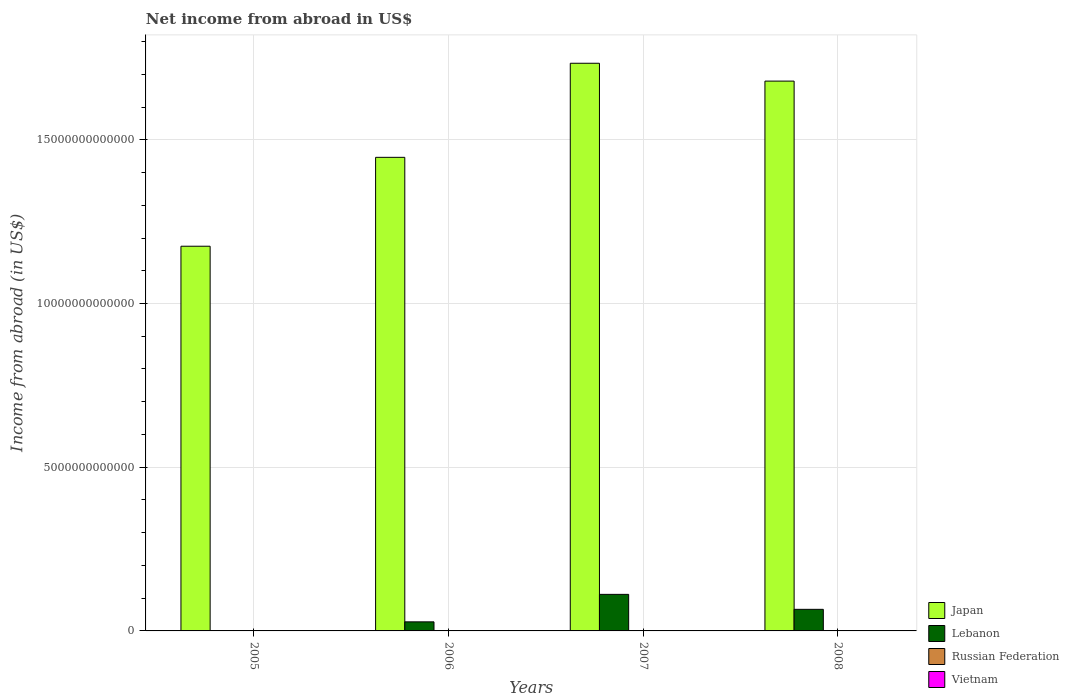Are the number of bars per tick equal to the number of legend labels?
Keep it short and to the point. No. Are the number of bars on each tick of the X-axis equal?
Your response must be concise. No. How many bars are there on the 3rd tick from the left?
Provide a succinct answer. 2. Across all years, what is the maximum net income from abroad in Lebanon?
Offer a very short reply. 1.12e+12. In which year was the net income from abroad in Lebanon maximum?
Your answer should be very brief. 2007. What is the total net income from abroad in Lebanon in the graph?
Make the answer very short. 2.05e+12. What is the difference between the net income from abroad in Lebanon in 2007 and that in 2008?
Keep it short and to the point. 4.58e+11. What is the difference between the net income from abroad in Lebanon in 2008 and the net income from abroad in Japan in 2007?
Give a very brief answer. -1.67e+13. What is the average net income from abroad in Lebanon per year?
Your answer should be compact. 5.13e+11. What is the ratio of the net income from abroad in Japan in 2005 to that in 2007?
Make the answer very short. 0.68. Is the net income from abroad in Japan in 2007 less than that in 2008?
Keep it short and to the point. No. What is the difference between the highest and the second highest net income from abroad in Japan?
Offer a very short reply. 5.45e+11. What is the difference between the highest and the lowest net income from abroad in Lebanon?
Offer a terse response. 1.12e+12. In how many years, is the net income from abroad in Japan greater than the average net income from abroad in Japan taken over all years?
Your answer should be very brief. 2. Is the sum of the net income from abroad in Japan in 2007 and 2008 greater than the maximum net income from abroad in Lebanon across all years?
Ensure brevity in your answer.  Yes. Is it the case that in every year, the sum of the net income from abroad in Vietnam and net income from abroad in Russian Federation is greater than the sum of net income from abroad in Japan and net income from abroad in Lebanon?
Give a very brief answer. No. Is it the case that in every year, the sum of the net income from abroad in Russian Federation and net income from abroad in Lebanon is greater than the net income from abroad in Japan?
Make the answer very short. No. What is the difference between two consecutive major ticks on the Y-axis?
Provide a succinct answer. 5.00e+12. Are the values on the major ticks of Y-axis written in scientific E-notation?
Keep it short and to the point. No. Does the graph contain any zero values?
Your answer should be very brief. Yes. Does the graph contain grids?
Offer a terse response. Yes. How are the legend labels stacked?
Your answer should be very brief. Vertical. What is the title of the graph?
Your response must be concise. Net income from abroad in US$. Does "Singapore" appear as one of the legend labels in the graph?
Offer a terse response. No. What is the label or title of the Y-axis?
Make the answer very short. Income from abroad (in US$). What is the Income from abroad (in US$) in Japan in 2005?
Offer a very short reply. 1.17e+13. What is the Income from abroad (in US$) in Russian Federation in 2005?
Make the answer very short. 0. What is the Income from abroad (in US$) of Vietnam in 2005?
Your response must be concise. 0. What is the Income from abroad (in US$) in Japan in 2006?
Make the answer very short. 1.45e+13. What is the Income from abroad (in US$) of Lebanon in 2006?
Your answer should be very brief. 2.77e+11. What is the Income from abroad (in US$) in Japan in 2007?
Offer a very short reply. 1.73e+13. What is the Income from abroad (in US$) of Lebanon in 2007?
Keep it short and to the point. 1.12e+12. What is the Income from abroad (in US$) in Japan in 2008?
Your answer should be compact. 1.68e+13. What is the Income from abroad (in US$) in Lebanon in 2008?
Offer a terse response. 6.59e+11. What is the Income from abroad (in US$) in Vietnam in 2008?
Give a very brief answer. 0. Across all years, what is the maximum Income from abroad (in US$) of Japan?
Your answer should be very brief. 1.73e+13. Across all years, what is the maximum Income from abroad (in US$) of Lebanon?
Your answer should be very brief. 1.12e+12. Across all years, what is the minimum Income from abroad (in US$) of Japan?
Make the answer very short. 1.17e+13. Across all years, what is the minimum Income from abroad (in US$) of Lebanon?
Offer a terse response. 0. What is the total Income from abroad (in US$) in Japan in the graph?
Give a very brief answer. 6.03e+13. What is the total Income from abroad (in US$) of Lebanon in the graph?
Keep it short and to the point. 2.05e+12. What is the total Income from abroad (in US$) in Vietnam in the graph?
Provide a succinct answer. 0. What is the difference between the Income from abroad (in US$) in Japan in 2005 and that in 2006?
Ensure brevity in your answer.  -2.72e+12. What is the difference between the Income from abroad (in US$) in Japan in 2005 and that in 2007?
Keep it short and to the point. -5.59e+12. What is the difference between the Income from abroad (in US$) in Japan in 2005 and that in 2008?
Your answer should be compact. -5.04e+12. What is the difference between the Income from abroad (in US$) in Japan in 2006 and that in 2007?
Your response must be concise. -2.87e+12. What is the difference between the Income from abroad (in US$) of Lebanon in 2006 and that in 2007?
Keep it short and to the point. -8.40e+11. What is the difference between the Income from abroad (in US$) of Japan in 2006 and that in 2008?
Give a very brief answer. -2.33e+12. What is the difference between the Income from abroad (in US$) in Lebanon in 2006 and that in 2008?
Provide a succinct answer. -3.82e+11. What is the difference between the Income from abroad (in US$) of Japan in 2007 and that in 2008?
Give a very brief answer. 5.45e+11. What is the difference between the Income from abroad (in US$) in Lebanon in 2007 and that in 2008?
Provide a succinct answer. 4.58e+11. What is the difference between the Income from abroad (in US$) of Japan in 2005 and the Income from abroad (in US$) of Lebanon in 2006?
Offer a very short reply. 1.15e+13. What is the difference between the Income from abroad (in US$) in Japan in 2005 and the Income from abroad (in US$) in Lebanon in 2007?
Your response must be concise. 1.06e+13. What is the difference between the Income from abroad (in US$) in Japan in 2005 and the Income from abroad (in US$) in Lebanon in 2008?
Provide a succinct answer. 1.11e+13. What is the difference between the Income from abroad (in US$) in Japan in 2006 and the Income from abroad (in US$) in Lebanon in 2007?
Offer a very short reply. 1.33e+13. What is the difference between the Income from abroad (in US$) of Japan in 2006 and the Income from abroad (in US$) of Lebanon in 2008?
Ensure brevity in your answer.  1.38e+13. What is the difference between the Income from abroad (in US$) of Japan in 2007 and the Income from abroad (in US$) of Lebanon in 2008?
Your answer should be compact. 1.67e+13. What is the average Income from abroad (in US$) in Japan per year?
Offer a terse response. 1.51e+13. What is the average Income from abroad (in US$) in Lebanon per year?
Provide a short and direct response. 5.13e+11. In the year 2006, what is the difference between the Income from abroad (in US$) of Japan and Income from abroad (in US$) of Lebanon?
Your answer should be very brief. 1.42e+13. In the year 2007, what is the difference between the Income from abroad (in US$) in Japan and Income from abroad (in US$) in Lebanon?
Give a very brief answer. 1.62e+13. In the year 2008, what is the difference between the Income from abroad (in US$) in Japan and Income from abroad (in US$) in Lebanon?
Ensure brevity in your answer.  1.61e+13. What is the ratio of the Income from abroad (in US$) in Japan in 2005 to that in 2006?
Make the answer very short. 0.81. What is the ratio of the Income from abroad (in US$) of Japan in 2005 to that in 2007?
Your answer should be very brief. 0.68. What is the ratio of the Income from abroad (in US$) of Japan in 2005 to that in 2008?
Keep it short and to the point. 0.7. What is the ratio of the Income from abroad (in US$) in Japan in 2006 to that in 2007?
Make the answer very short. 0.83. What is the ratio of the Income from abroad (in US$) of Lebanon in 2006 to that in 2007?
Offer a terse response. 0.25. What is the ratio of the Income from abroad (in US$) in Japan in 2006 to that in 2008?
Make the answer very short. 0.86. What is the ratio of the Income from abroad (in US$) in Lebanon in 2006 to that in 2008?
Keep it short and to the point. 0.42. What is the ratio of the Income from abroad (in US$) of Japan in 2007 to that in 2008?
Ensure brevity in your answer.  1.03. What is the ratio of the Income from abroad (in US$) in Lebanon in 2007 to that in 2008?
Make the answer very short. 1.69. What is the difference between the highest and the second highest Income from abroad (in US$) of Japan?
Give a very brief answer. 5.45e+11. What is the difference between the highest and the second highest Income from abroad (in US$) in Lebanon?
Your response must be concise. 4.58e+11. What is the difference between the highest and the lowest Income from abroad (in US$) in Japan?
Your answer should be very brief. 5.59e+12. What is the difference between the highest and the lowest Income from abroad (in US$) of Lebanon?
Keep it short and to the point. 1.12e+12. 